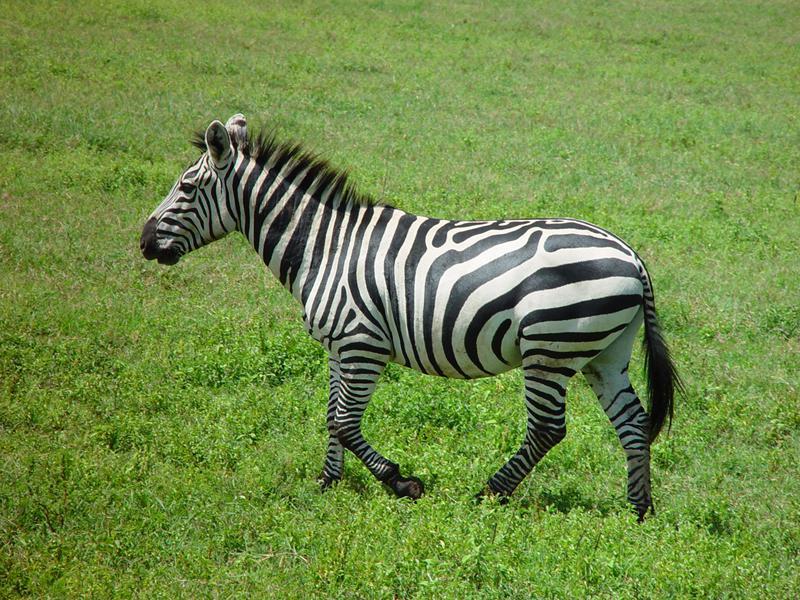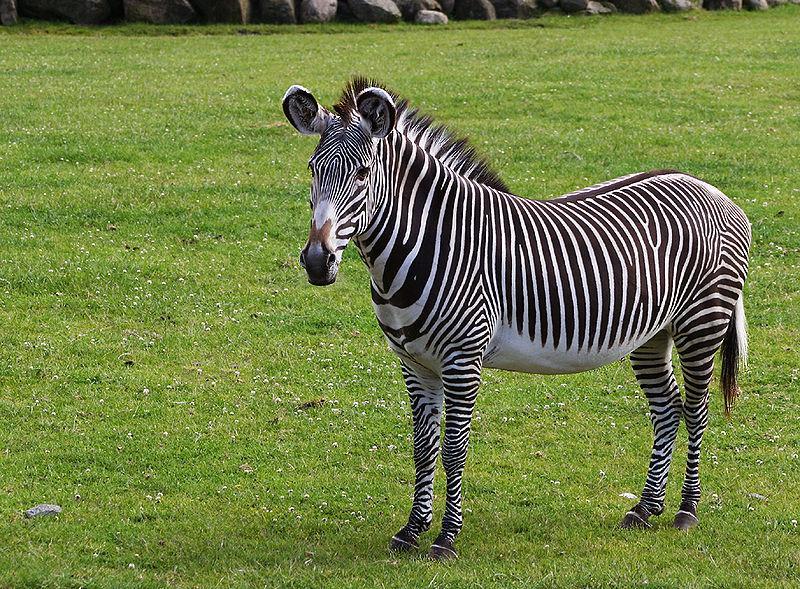The first image is the image on the left, the second image is the image on the right. Given the left and right images, does the statement "There are three zebras and one of them is a juvenile." hold true? Answer yes or no. No. The first image is the image on the left, the second image is the image on the right. Considering the images on both sides, is "There are two zebras, one adult and one child facing right." valid? Answer yes or no. No. 